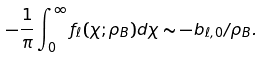Convert formula to latex. <formula><loc_0><loc_0><loc_500><loc_500>- \frac { 1 } { \pi } \int _ { 0 } ^ { \infty } f _ { \ell } ( \chi ; \rho _ { B } ) d \chi \sim - b _ { \ell , 0 } / \rho _ { B } .</formula> 